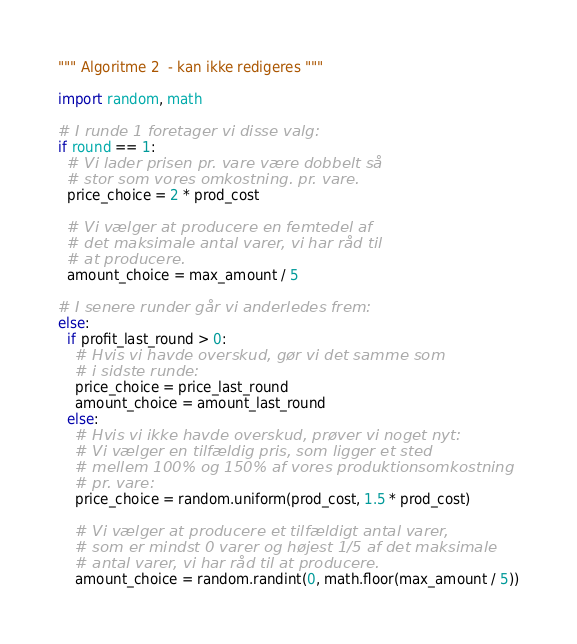<code> <loc_0><loc_0><loc_500><loc_500><_Python_>""" Algoritme 2  - kan ikke redigeres """

import random, math

# I runde 1 foretager vi disse valg:
if round == 1:
  # Vi lader prisen pr. vare være dobbelt så 
  # stor som vores omkostning. pr. vare. 
  price_choice = 2 * prod_cost

  # Vi vælger at producere en femtedel af 
  # det maksimale antal varer, vi har råd til 
  # at producere. 
  amount_choice = max_amount / 5

# I senere runder går vi anderledes frem:
else:
  if profit_last_round > 0:
    # Hvis vi havde overskud, gør vi det samme som 
    # i sidste runde:
    price_choice = price_last_round
    amount_choice = amount_last_round
  else:
    # Hvis vi ikke havde overskud, prøver vi noget nyt:
    # Vi vælger en tilfældig pris, som ligger et sted
    # mellem 100% og 150% af vores produktionsomkostning
    # pr. vare:
    price_choice = random.uniform(prod_cost, 1.5 * prod_cost)

    # Vi vælger at producere et tilfældigt antal varer, 
    # som er mindst 0 varer og højest 1/5 af det maksimale
    # antal varer, vi har råd til at producere. 
    amount_choice = random.randint(0, math.floor(max_amount / 5))
</code> 